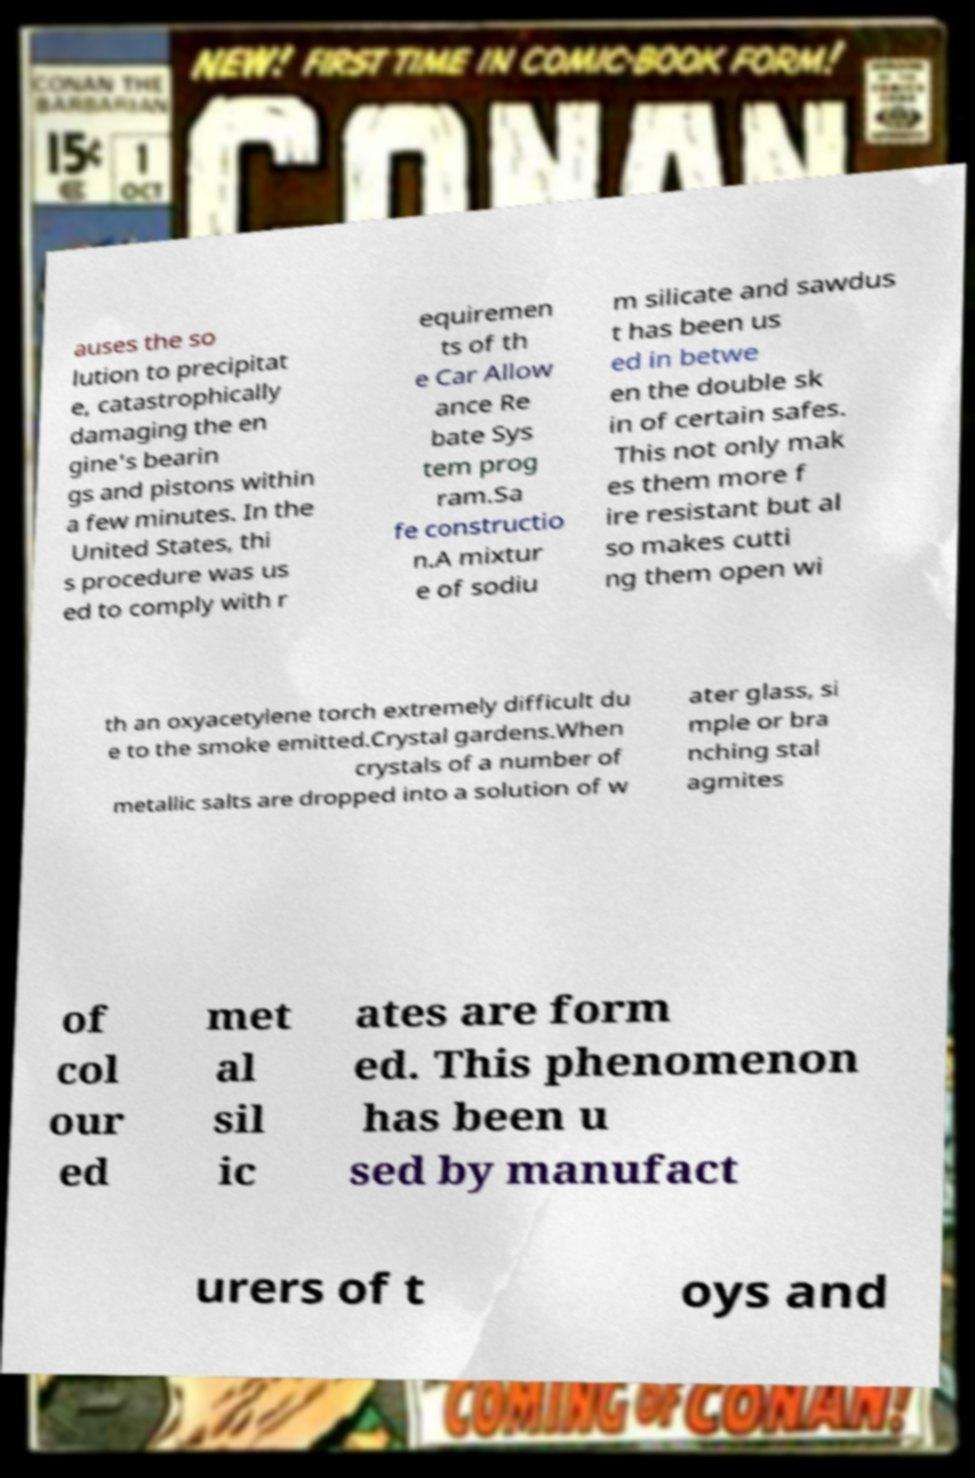Can you accurately transcribe the text from the provided image for me? auses the so lution to precipitat e, catastrophically damaging the en gine's bearin gs and pistons within a few minutes. In the United States, thi s procedure was us ed to comply with r equiremen ts of th e Car Allow ance Re bate Sys tem prog ram.Sa fe constructio n.A mixtur e of sodiu m silicate and sawdus t has been us ed in betwe en the double sk in of certain safes. This not only mak es them more f ire resistant but al so makes cutti ng them open wi th an oxyacetylene torch extremely difficult du e to the smoke emitted.Crystal gardens.When crystals of a number of metallic salts are dropped into a solution of w ater glass, si mple or bra nching stal agmites of col our ed met al sil ic ates are form ed. This phenomenon has been u sed by manufact urers of t oys and 